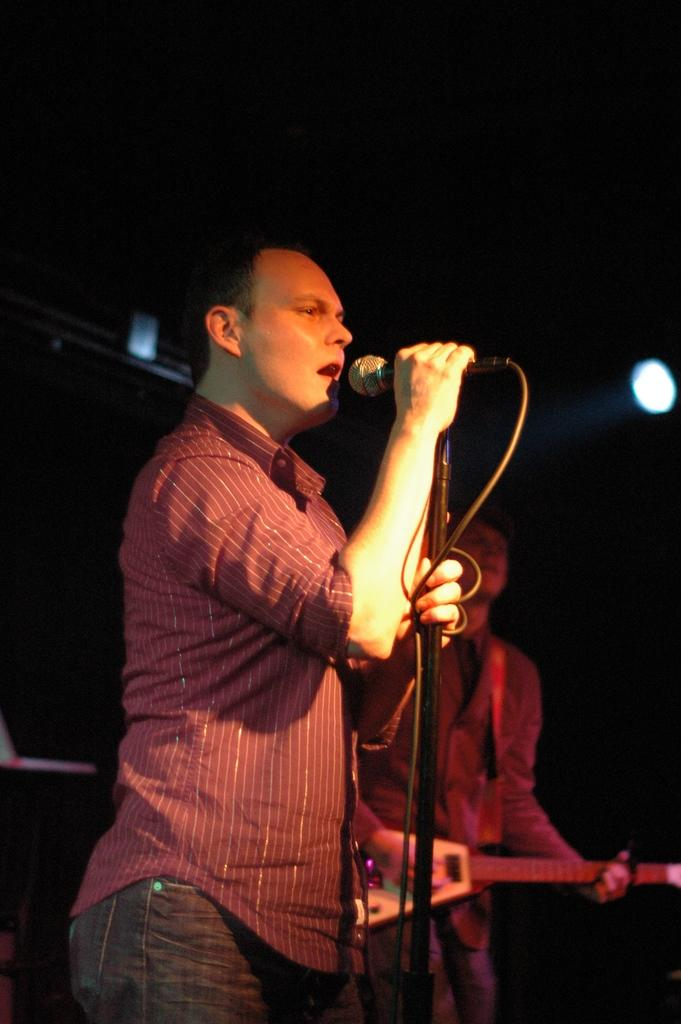What is the man in the image wearing? The man is wearing a red shirt and jeans pants. What is the man holding in the image? The man is holding a microphone. What is the man doing in the image? The man is singing. Is there anyone else in the image besides the man with the microphone? Yes, there is another man in the image who is playing a guitar. What type of sack can be seen in the image? There is no sack present in the image. How many cups are visible in the image? There are no cups visible in the image. 